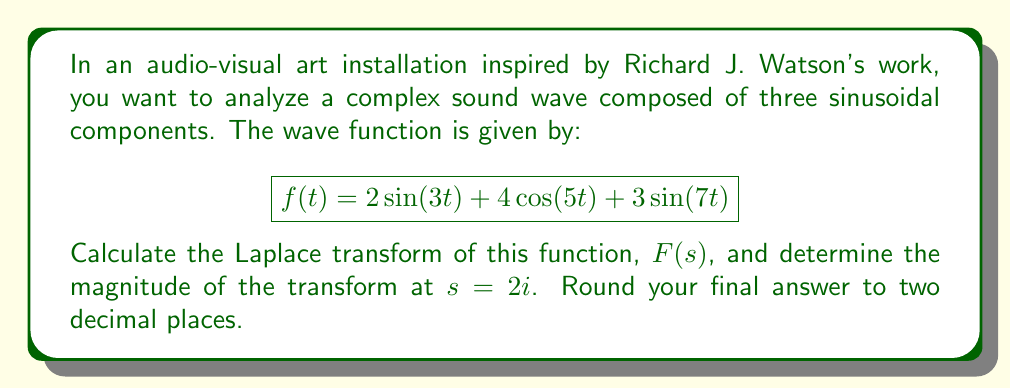Teach me how to tackle this problem. To solve this problem, we'll follow these steps:

1) First, recall the Laplace transforms of sine and cosine functions:
   $$\mathcal{L}\{\sin(at)\} = \frac{a}{s^2 + a^2}$$
   $$\mathcal{L}\{\cos(at)\} = \frac{s}{s^2 + a^2}$$

2) Now, let's apply the Laplace transform to each component of our function:

   For $2\sin(3t)$: 
   $$\mathcal{L}\{2\sin(3t)\} = 2 \cdot \frac{3}{s^2 + 3^2} = \frac{6}{s^2 + 9}$$

   For $4\cos(5t)$:
   $$\mathcal{L}\{4\cos(5t)\} = 4 \cdot \frac{s}{s^2 + 5^2} = \frac{4s}{s^2 + 25}$$

   For $3\sin(7t)$:
   $$\mathcal{L}\{3\sin(7t)\} = 3 \cdot \frac{7}{s^2 + 7^2} = \frac{21}{s^2 + 49}$$

3) The Laplace transform of the sum is the sum of the Laplace transforms, so:

   $$F(s) = \frac{6}{s^2 + 9} + \frac{4s}{s^2 + 25} + \frac{21}{s^2 + 49}$$

4) Now, we need to evaluate $|F(2i)|$. Let's substitute $s = 2i$ into our expression:

   $$F(2i) = \frac{6}{(2i)^2 + 9} + \frac{4(2i)}{(2i)^2 + 25} + \frac{21}{(2i)^2 + 49}$$

5) Simplify:
   $$F(2i) = \frac{6}{-4 + 9} + \frac{8i}{-4 + 25} + \frac{21}{-4 + 49}$$
   $$= \frac{6}{5} + \frac{8i}{21} + \frac{21}{45}$$

6) To find the magnitude, we need to calculate $|F(2i)|$:

   $$|F(2i)| = \sqrt{(\frac{6}{5} + \frac{21}{45})^2 + (\frac{8}{21})^2}$$

7) Calculate:
   $$|F(2i)| = \sqrt{(1.2 + 0.4667)^2 + (0.3810)^2}$$
   $$= \sqrt{2.7778}$$
   $$\approx 1.67$$
Answer: $|F(2i)| \approx 1.67$ 